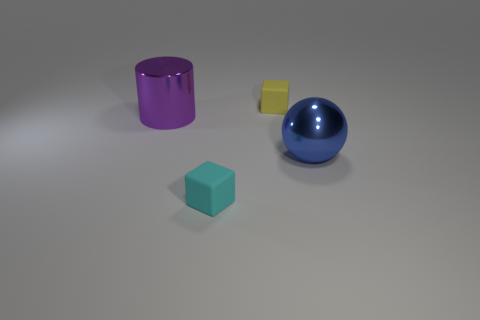How many yellow things are either big shiny balls or matte blocks?
Ensure brevity in your answer.  1. There is a tiny object behind the large purple metallic object; is its shape the same as the tiny object in front of the purple cylinder?
Keep it short and to the point. Yes. How many objects are either tiny matte objects or large blue spheres on the right side of the cylinder?
Offer a very short reply. 3. There is a thing that is both on the right side of the large shiny cylinder and left of the yellow cube; what is its material?
Keep it short and to the point. Rubber. What is the big blue object in front of the yellow block made of?
Keep it short and to the point. Metal. What is the color of the other tiny block that is made of the same material as the yellow block?
Your answer should be compact. Cyan. Does the small yellow rubber thing have the same shape as the tiny thing in front of the large blue thing?
Ensure brevity in your answer.  Yes. Are there any blue metal objects in front of the large purple cylinder?
Offer a very short reply. Yes. There is a blue ball; does it have the same size as the cylinder that is behind the cyan cube?
Make the answer very short. Yes. Is there a small yellow matte thing that has the same shape as the small cyan matte object?
Offer a terse response. Yes. 